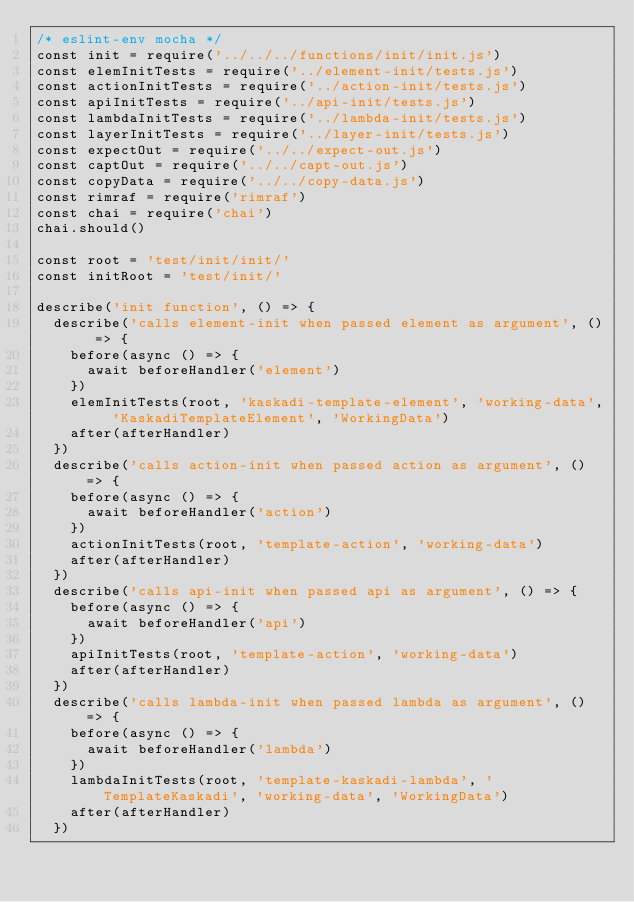Convert code to text. <code><loc_0><loc_0><loc_500><loc_500><_JavaScript_>/* eslint-env mocha */
const init = require('../../../functions/init/init.js')
const elemInitTests = require('../element-init/tests.js')
const actionInitTests = require('../action-init/tests.js')
const apiInitTests = require('../api-init/tests.js')
const lambdaInitTests = require('../lambda-init/tests.js')
const layerInitTests = require('../layer-init/tests.js')
const expectOut = require('../../expect-out.js')
const captOut = require('../../capt-out.js')
const copyData = require('../../copy-data.js')
const rimraf = require('rimraf')
const chai = require('chai')
chai.should()

const root = 'test/init/init/'
const initRoot = 'test/init/'

describe('init function', () => {
  describe('calls element-init when passed element as argument', () => {
    before(async () => {
      await beforeHandler('element')
    })
    elemInitTests(root, 'kaskadi-template-element', 'working-data', 'KaskadiTemplateElement', 'WorkingData')
    after(afterHandler)
  })
  describe('calls action-init when passed action as argument', () => {
    before(async () => {
      await beforeHandler('action')
    })
    actionInitTests(root, 'template-action', 'working-data')
    after(afterHandler)
  })
  describe('calls api-init when passed api as argument', () => {
    before(async () => {
      await beforeHandler('api')
    })
    apiInitTests(root, 'template-action', 'working-data')
    after(afterHandler)
  })
  describe('calls lambda-init when passed lambda as argument', () => {
    before(async () => {
      await beforeHandler('lambda')
    })
    lambdaInitTests(root, 'template-kaskadi-lambda', 'TemplateKaskadi', 'working-data', 'WorkingData')
    after(afterHandler)
  })</code> 